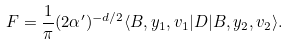<formula> <loc_0><loc_0><loc_500><loc_500>F = \frac { 1 } { \pi } ( 2 \alpha ^ { \prime } ) ^ { - d / 2 } \langle B , y _ { 1 } , v _ { 1 } | D | B , y _ { 2 } , v _ { 2 } \rangle .</formula> 